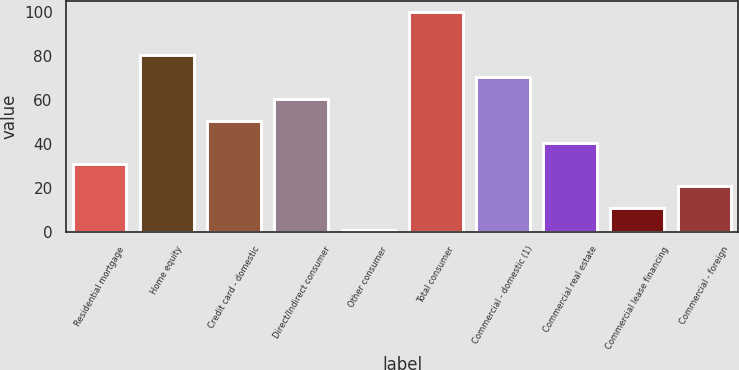Convert chart. <chart><loc_0><loc_0><loc_500><loc_500><bar_chart><fcel>Residential mortgage<fcel>Home equity<fcel>Credit card - domestic<fcel>Direct/Indirect consumer<fcel>Other consumer<fcel>Total consumer<fcel>Commercial - domestic (1)<fcel>Commercial real estate<fcel>Commercial lease financing<fcel>Commercial - foreign<nl><fcel>30.61<fcel>80.16<fcel>50.43<fcel>60.34<fcel>0.88<fcel>99.98<fcel>70.25<fcel>40.52<fcel>10.79<fcel>20.7<nl></chart> 